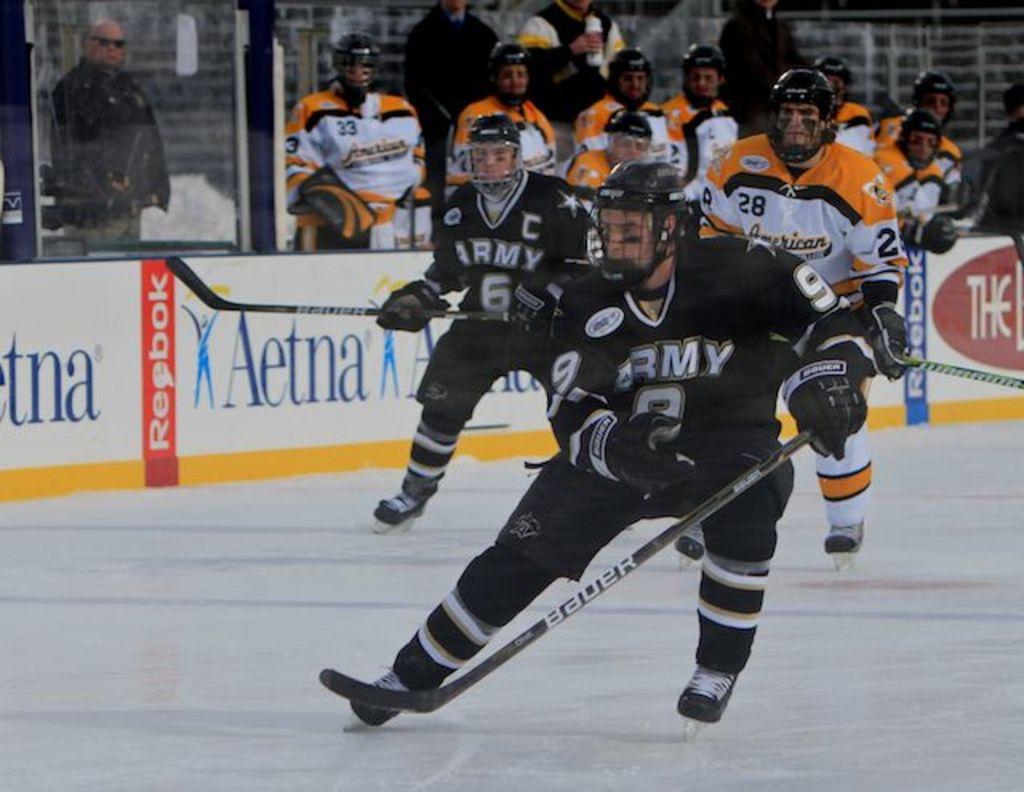What team do the players in black play for?
Give a very brief answer. Army. Who sponsors the rink?
Provide a succinct answer. Aetna. 